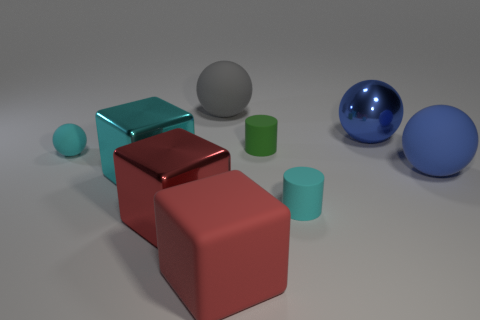What number of small cylinders are made of the same material as the gray thing?
Offer a terse response. 2. There is a big matte cube; what number of cyan objects are right of it?
Offer a very short reply. 1. What is the size of the green matte cylinder?
Offer a very short reply. Small. What color is the matte cube that is the same size as the blue shiny sphere?
Make the answer very short. Red. Are there any other metallic spheres that have the same color as the small ball?
Provide a succinct answer. No. What is the cyan cube made of?
Offer a terse response. Metal. How many red metal cylinders are there?
Make the answer very short. 0. There is a big block that is to the right of the gray rubber object; is its color the same as the large shiny object in front of the large cyan metal cube?
Your answer should be very brief. Yes. What size is the rubber ball that is the same color as the shiny ball?
Keep it short and to the point. Large. How many other objects are there of the same size as the metal ball?
Offer a terse response. 5. 